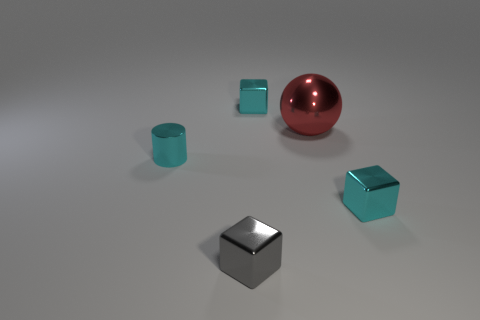Add 1 cyan metallic cubes. How many objects exist? 6 Subtract all cylinders. How many objects are left? 4 Add 2 big cyan metal cylinders. How many big cyan metal cylinders exist? 2 Subtract 0 blue cubes. How many objects are left? 5 Subtract all red balls. Subtract all tiny cyan objects. How many objects are left? 1 Add 2 red shiny things. How many red shiny things are left? 3 